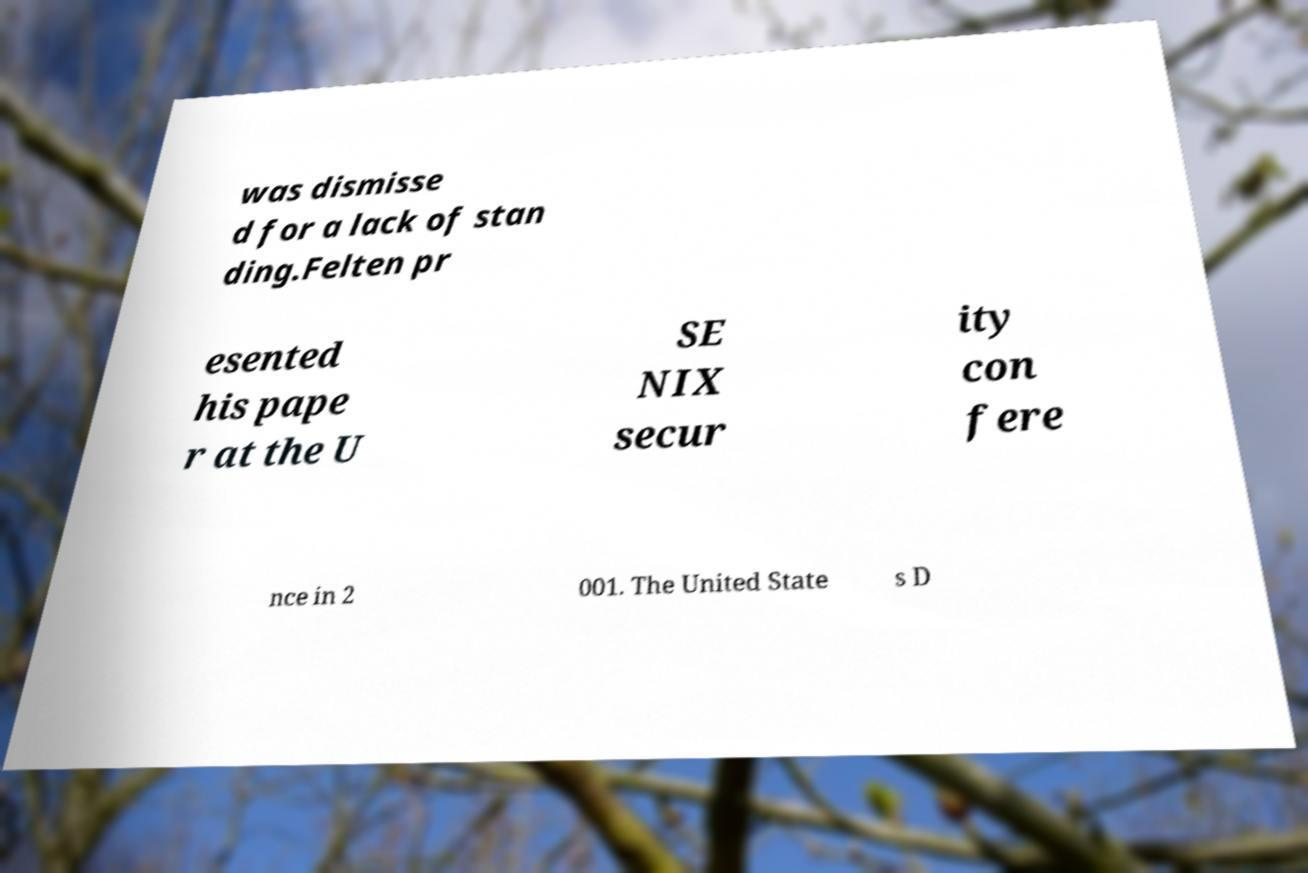Could you extract and type out the text from this image? was dismisse d for a lack of stan ding.Felten pr esented his pape r at the U SE NIX secur ity con fere nce in 2 001. The United State s D 